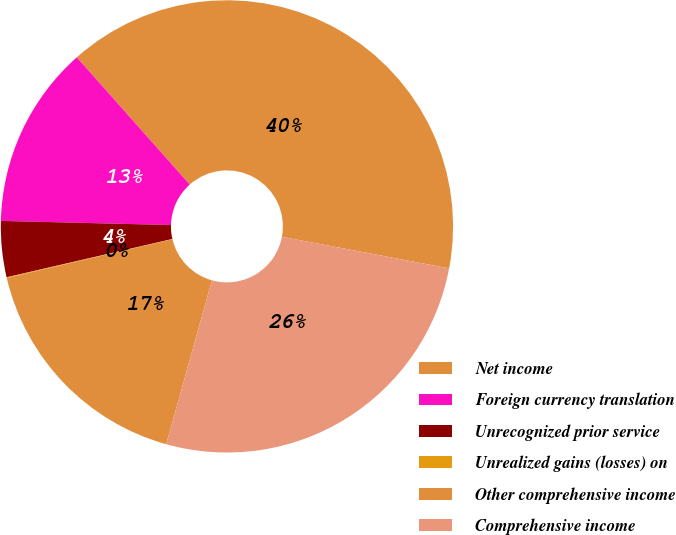<chart> <loc_0><loc_0><loc_500><loc_500><pie_chart><fcel>Net income<fcel>Foreign currency translation<fcel>Unrecognized prior service<fcel>Unrealized gains (losses) on<fcel>Other comprehensive income<fcel>Comprehensive income<nl><fcel>39.53%<fcel>13.06%<fcel>4.0%<fcel>0.05%<fcel>17.01%<fcel>26.36%<nl></chart> 